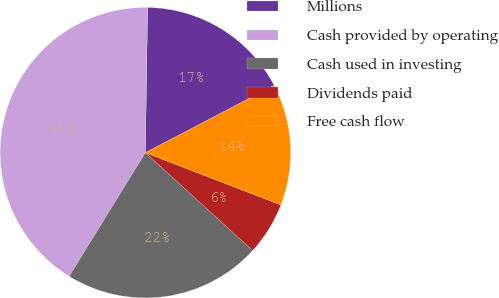<chart> <loc_0><loc_0><loc_500><loc_500><pie_chart><fcel>Millions<fcel>Cash provided by operating<fcel>Cash used in investing<fcel>Dividends paid<fcel>Free cash flow<nl><fcel>17.09%<fcel>41.46%<fcel>22.02%<fcel>5.91%<fcel>13.53%<nl></chart> 